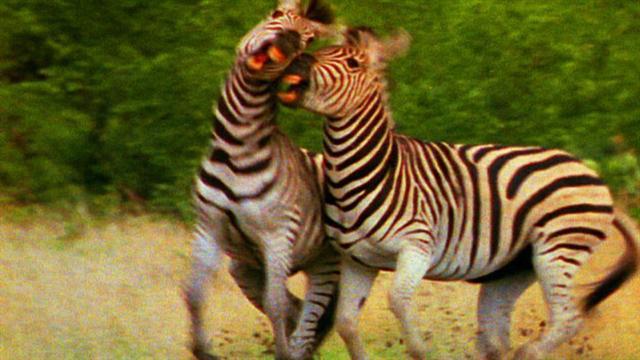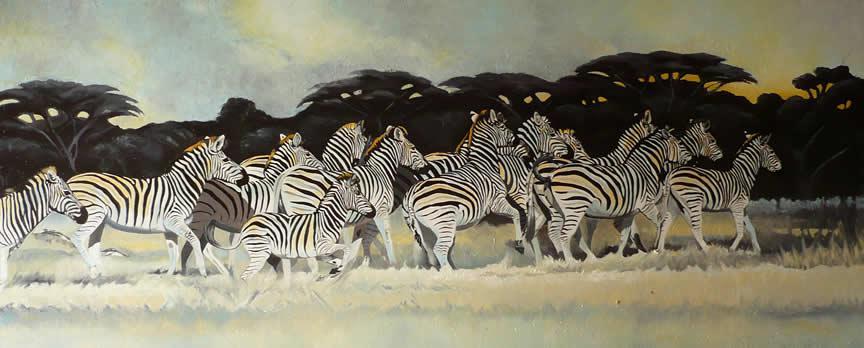The first image is the image on the left, the second image is the image on the right. Examine the images to the left and right. Is the description "One image shows at least four zebras running forward, and the other image shows at least two zebras running leftward." accurate? Answer yes or no. No. The first image is the image on the left, the second image is the image on the right. For the images displayed, is the sentence "There are two zebras next to each other moving left and forward." factually correct? Answer yes or no. Yes. 